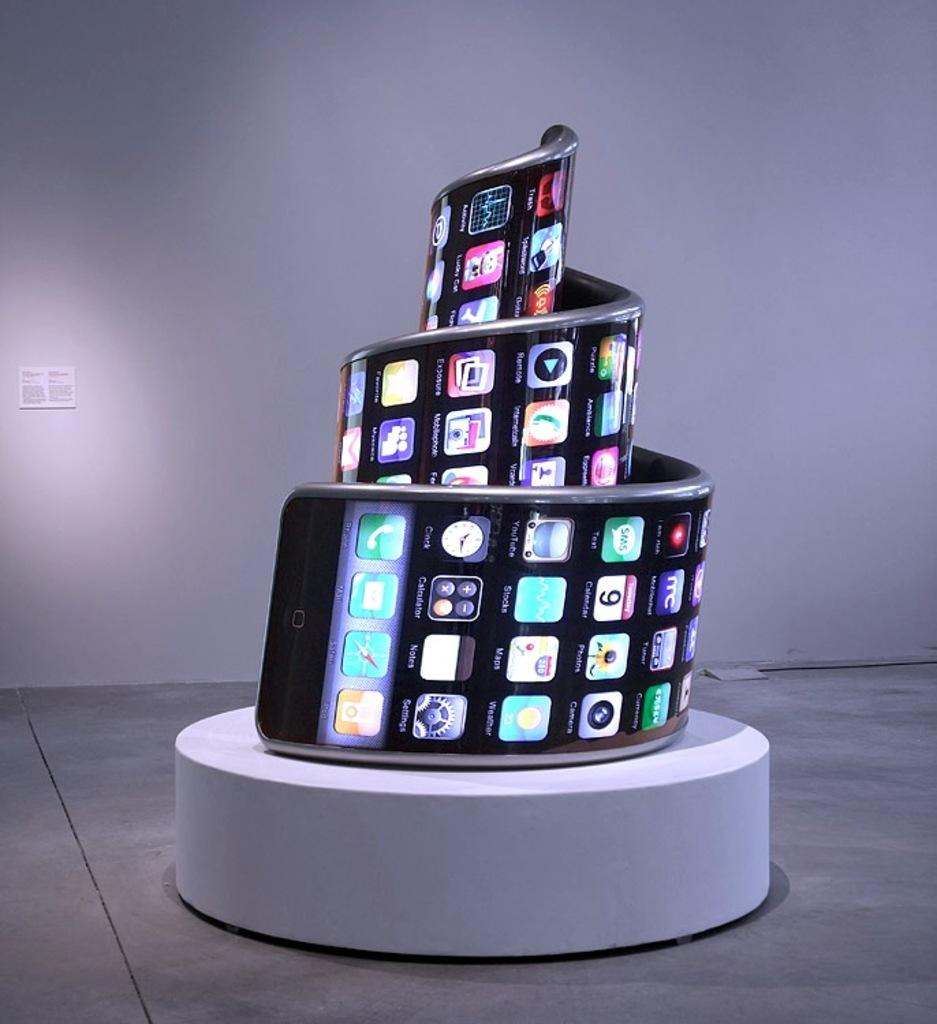What is the main subject of the image? The main subject of the image is a mobile. How is the mobile arranged in the image? The mobile is twisted into a spring-like structure. Where is the mobile located in the image? The mobile is on a platform on the floor. What can be seen in the background of the image? There is a small board on the wall in the background of the image. Can you hear the mobile crying in the image? There is no indication of sound or crying in the image, as it is a visual representation of a mobile. 